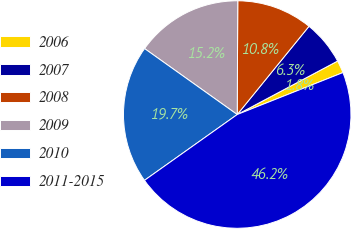Convert chart to OTSL. <chart><loc_0><loc_0><loc_500><loc_500><pie_chart><fcel>2006<fcel>2007<fcel>2008<fcel>2009<fcel>2010<fcel>2011-2015<nl><fcel>1.78%<fcel>6.34%<fcel>10.79%<fcel>15.23%<fcel>19.67%<fcel>46.19%<nl></chart> 